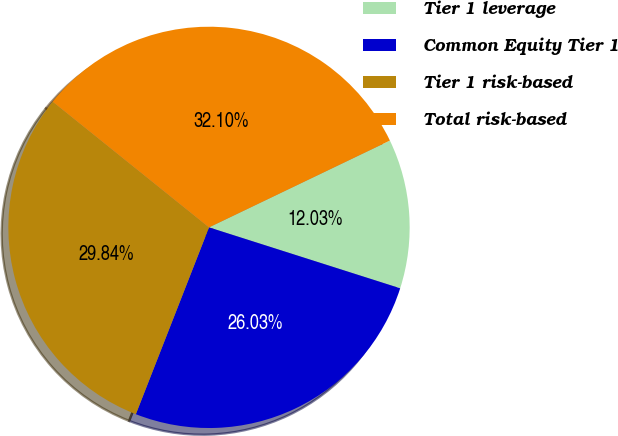<chart> <loc_0><loc_0><loc_500><loc_500><pie_chart><fcel>Tier 1 leverage<fcel>Common Equity Tier 1<fcel>Tier 1 risk-based<fcel>Total risk-based<nl><fcel>12.03%<fcel>26.03%<fcel>29.84%<fcel>32.1%<nl></chart> 